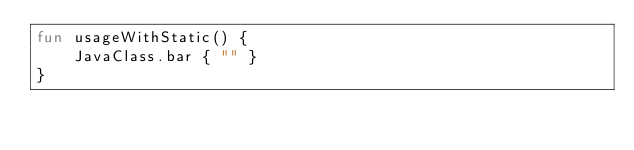<code> <loc_0><loc_0><loc_500><loc_500><_Kotlin_>fun usageWithStatic() {
    JavaClass.bar { "" }
}
</code> 